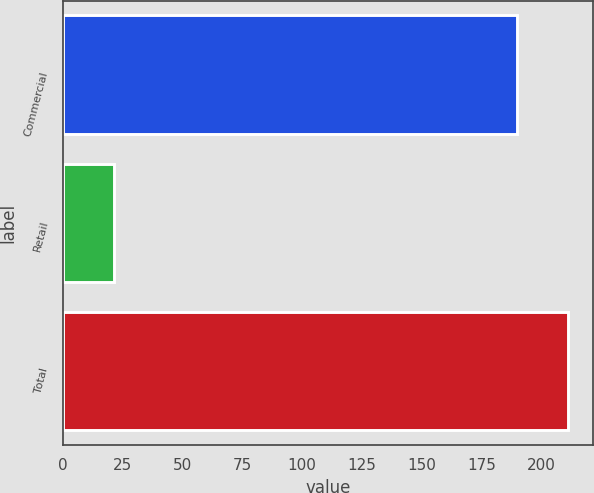Convert chart to OTSL. <chart><loc_0><loc_0><loc_500><loc_500><bar_chart><fcel>Commercial<fcel>Retail<fcel>Total<nl><fcel>189.7<fcel>21.3<fcel>211<nl></chart> 